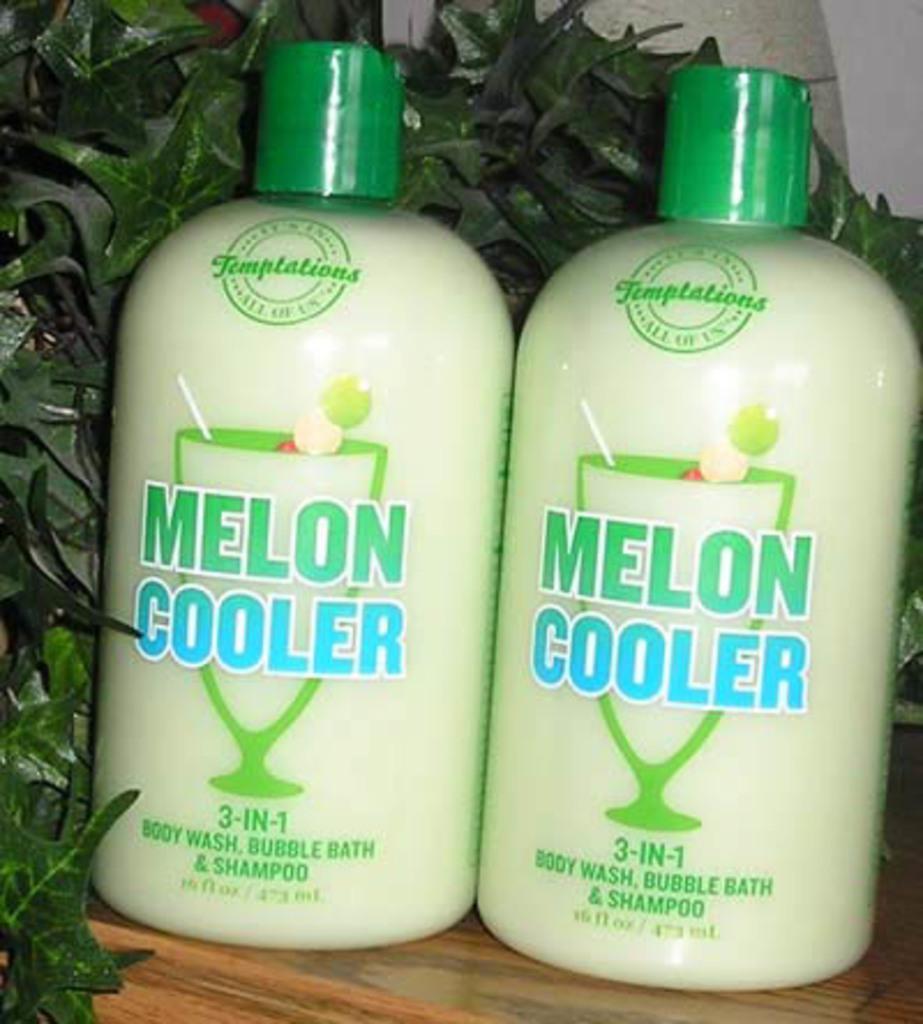How would you summarize this image in a sentence or two? In this image in the middle is a table on that there are two bottles with caps. In the background there are many leaves. 